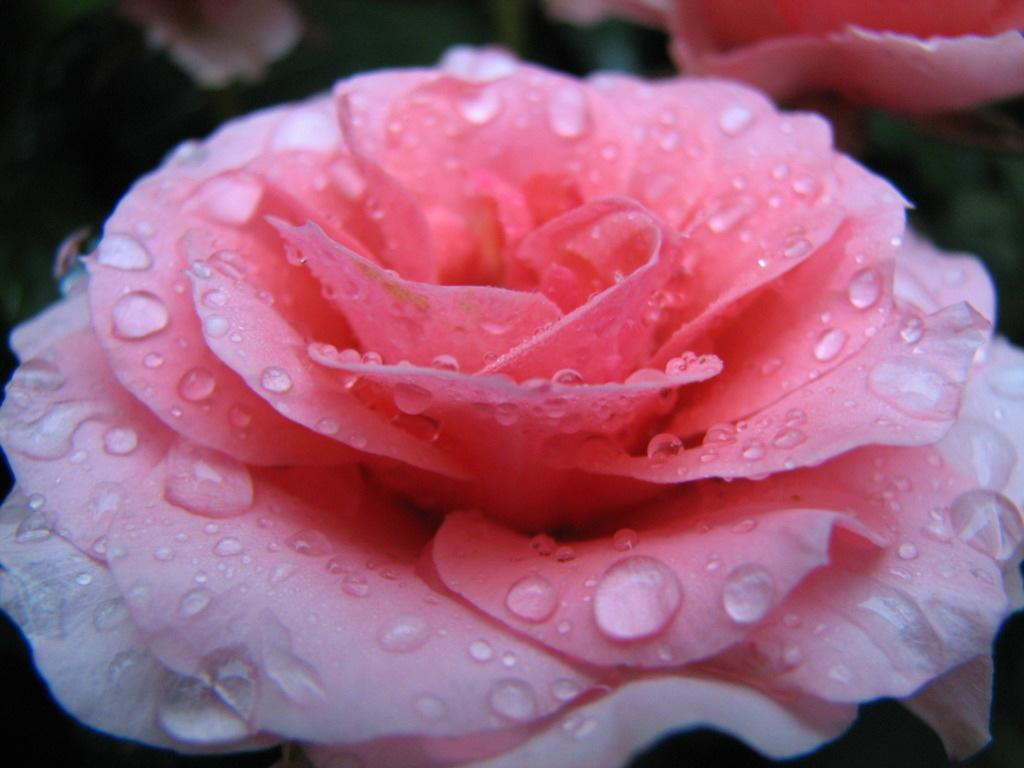What is the main subject in the foreground of the image? There is a pink flower in the foreground of the image. What can be observed on the pink flower? There are water droplets on the pink flower. What other flower can be seen in the image? There is another flower at the top of the image. How would you describe the overall focus of the image? The rest of the image is blurred. What type of jelly is being used to hold the flowers in place in the image? There is no jelly present in the image, and the flowers are not being held in place by any visible means. 